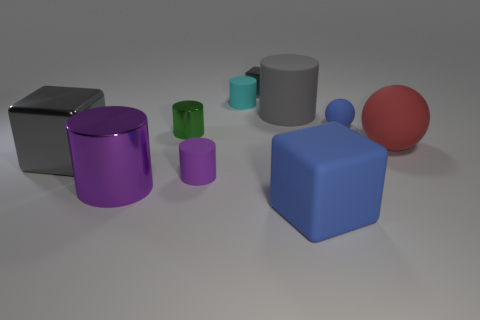Subtract all green cylinders. How many cylinders are left? 4 Subtract all gray rubber cylinders. How many cylinders are left? 4 Subtract all yellow cylinders. Subtract all purple spheres. How many cylinders are left? 5 Subtract all spheres. How many objects are left? 8 Subtract all gray cubes. Subtract all big objects. How many objects are left? 3 Add 6 red matte things. How many red matte things are left? 7 Add 9 tiny blue rubber objects. How many tiny blue rubber objects exist? 10 Subtract 0 brown spheres. How many objects are left? 10 